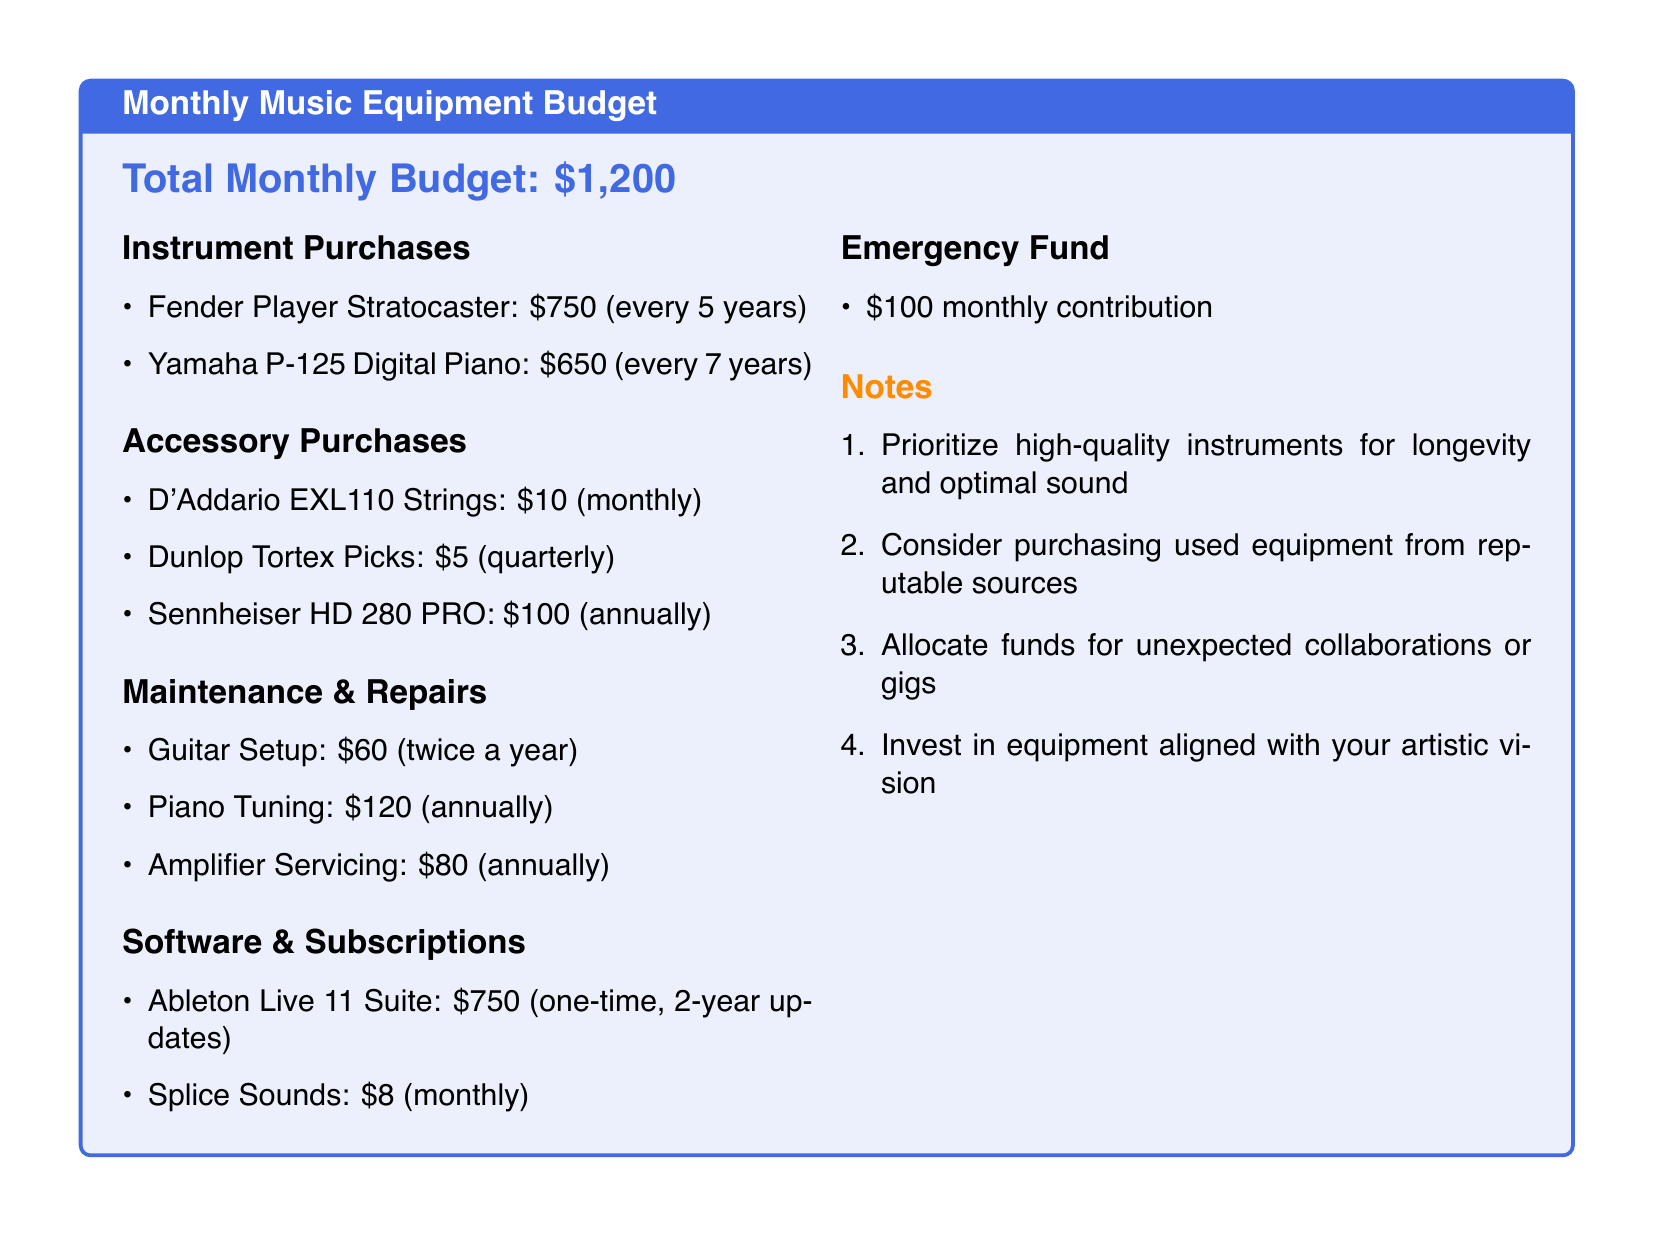What is the total monthly budget? The total monthly budget is specified at the beginning of the document.
Answer: $1,200 How much does a Fender Player Stratocaster cost? The document lists the cost of the Fender Player Stratocaster under Instrument Purchases.
Answer: $750 How often do you purchase D'Addario EXL110 Strings? The frequency of D'Addario EXL110 Strings purchases is mentioned in the Accessory Purchases section.
Answer: monthly What is the cost for piano tuning? The maintenance cost for piano tuning is listed under Maintenance & Repairs.
Answer: $120 How much is contributed to the Emergency Fund monthly? The document specifies the monthly contribution amount under Emergency Fund.
Answer: $100 What is the total cost of accessories purchased in a year? To find the total cost, we add the monthly, quarterly, and annual accessory costs listed in the document.
Answer: $145 How frequently is a guitar setup done? The frequency for guitar setup is mentioned in the Maintenance & Repairs section.
Answer: twice a year What software is included in the budget? The software listed in the document includes Ableton Live 11 Suite and Splice Sounds, found under Software & Subscriptions.
Answer: Ableton Live 11 Suite, Splice Sounds Why are high-quality instruments prioritized? The reason for prioritizing high-quality instruments is articulated in the Notes section of the document.
Answer: Longevity and optimal sound 